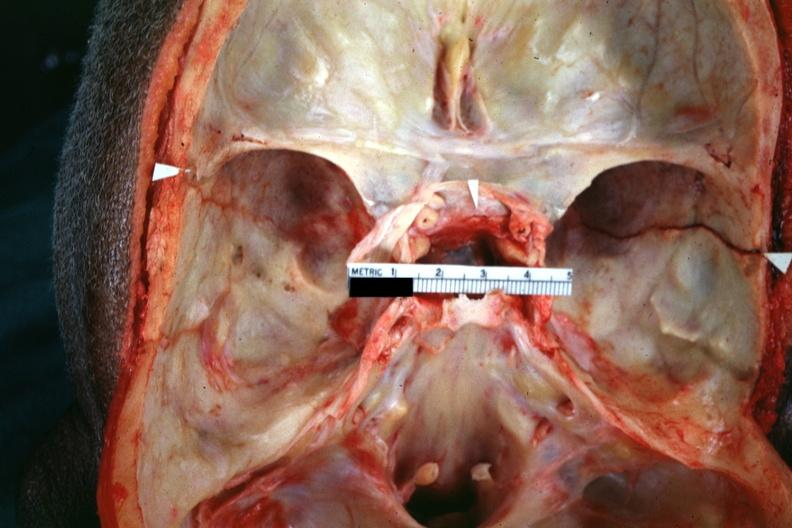does this image show close-up view well shown fracture line?
Answer the question using a single word or phrase. Yes 